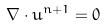Convert formula to latex. <formula><loc_0><loc_0><loc_500><loc_500>\nabla \cdot u ^ { n + 1 } = 0</formula> 